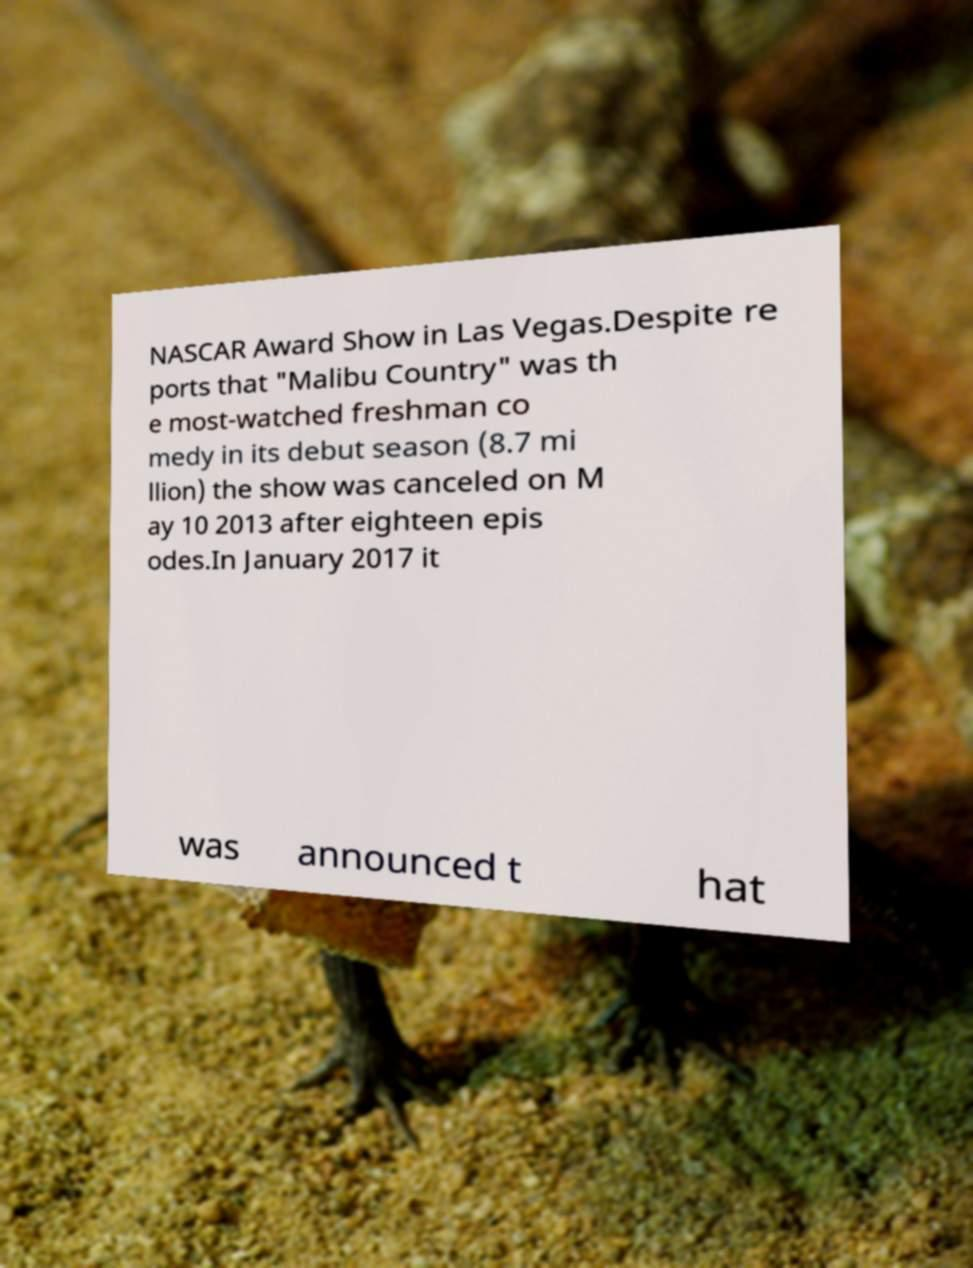Can you accurately transcribe the text from the provided image for me? NASCAR Award Show in Las Vegas.Despite re ports that "Malibu Country" was th e most-watched freshman co medy in its debut season (8.7 mi llion) the show was canceled on M ay 10 2013 after eighteen epis odes.In January 2017 it was announced t hat 